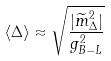Convert formula to latex. <formula><loc_0><loc_0><loc_500><loc_500>\langle \Delta \rangle \approx \sqrt { \frac { | \widetilde { m } ^ { 2 } _ { \Delta } | } { g _ { B - L } ^ { 2 } } }</formula> 